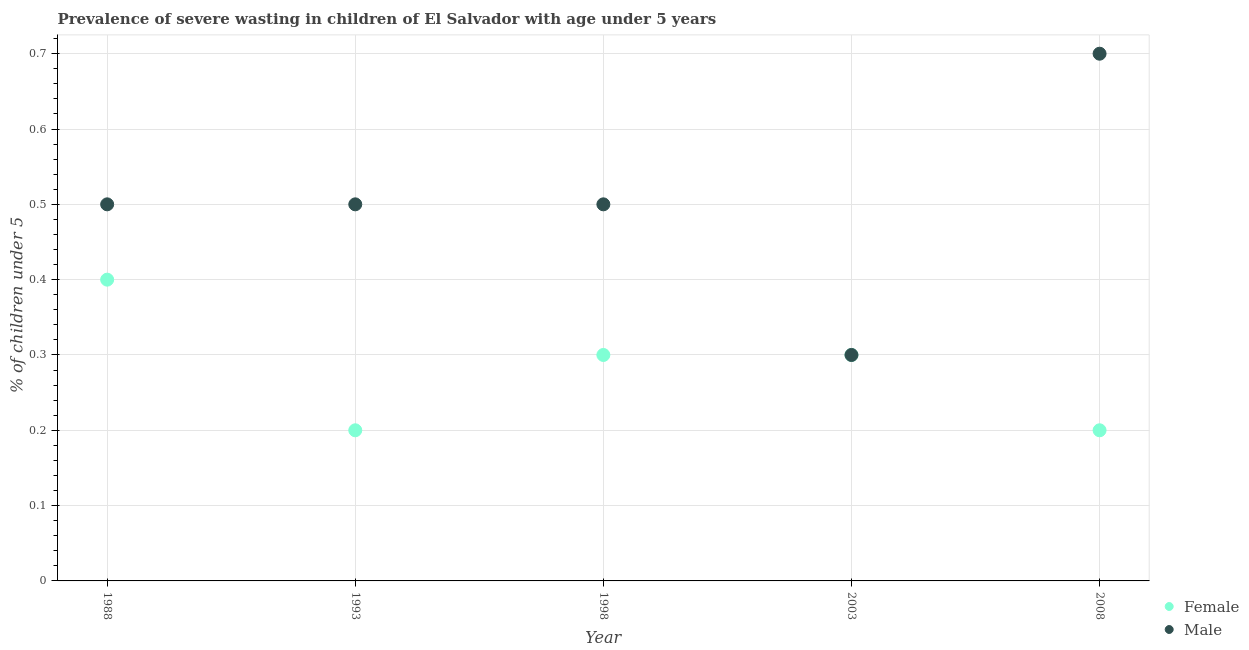Is the number of dotlines equal to the number of legend labels?
Keep it short and to the point. Yes. What is the percentage of undernourished female children in 2003?
Your answer should be very brief. 0.3. Across all years, what is the maximum percentage of undernourished male children?
Your response must be concise. 0.7. Across all years, what is the minimum percentage of undernourished female children?
Offer a very short reply. 0.2. In which year was the percentage of undernourished male children maximum?
Your answer should be very brief. 2008. What is the difference between the percentage of undernourished male children in 1993 and that in 2003?
Keep it short and to the point. 0.2. What is the difference between the percentage of undernourished male children in 1993 and the percentage of undernourished female children in 2008?
Your answer should be very brief. 0.3. In the year 2003, what is the difference between the percentage of undernourished male children and percentage of undernourished female children?
Give a very brief answer. 0. In how many years, is the percentage of undernourished female children greater than 0.02 %?
Provide a short and direct response. 5. Is the percentage of undernourished female children in 2003 less than that in 2008?
Your answer should be very brief. No. Is the difference between the percentage of undernourished male children in 1988 and 2008 greater than the difference between the percentage of undernourished female children in 1988 and 2008?
Your answer should be compact. No. What is the difference between the highest and the second highest percentage of undernourished male children?
Make the answer very short. 0.2. What is the difference between the highest and the lowest percentage of undernourished male children?
Offer a very short reply. 0.4. Does the percentage of undernourished female children monotonically increase over the years?
Ensure brevity in your answer.  No. Is the percentage of undernourished male children strictly greater than the percentage of undernourished female children over the years?
Offer a very short reply. No. How many dotlines are there?
Keep it short and to the point. 2. How many years are there in the graph?
Your answer should be very brief. 5. What is the difference between two consecutive major ticks on the Y-axis?
Give a very brief answer. 0.1. Are the values on the major ticks of Y-axis written in scientific E-notation?
Make the answer very short. No. Does the graph contain any zero values?
Ensure brevity in your answer.  No. Where does the legend appear in the graph?
Provide a short and direct response. Bottom right. How are the legend labels stacked?
Your response must be concise. Vertical. What is the title of the graph?
Your answer should be compact. Prevalence of severe wasting in children of El Salvador with age under 5 years. Does "2012 US$" appear as one of the legend labels in the graph?
Make the answer very short. No. What is the label or title of the Y-axis?
Your response must be concise.  % of children under 5. What is the  % of children under 5 in Female in 1988?
Offer a terse response. 0.4. What is the  % of children under 5 of Male in 1988?
Offer a very short reply. 0.5. What is the  % of children under 5 in Female in 1993?
Provide a succinct answer. 0.2. What is the  % of children under 5 in Female in 1998?
Offer a very short reply. 0.3. What is the  % of children under 5 in Female in 2003?
Ensure brevity in your answer.  0.3. What is the  % of children under 5 of Male in 2003?
Keep it short and to the point. 0.3. What is the  % of children under 5 in Female in 2008?
Offer a very short reply. 0.2. What is the  % of children under 5 of Male in 2008?
Give a very brief answer. 0.7. Across all years, what is the maximum  % of children under 5 of Female?
Your response must be concise. 0.4. Across all years, what is the maximum  % of children under 5 in Male?
Your answer should be very brief. 0.7. Across all years, what is the minimum  % of children under 5 in Female?
Your response must be concise. 0.2. Across all years, what is the minimum  % of children under 5 of Male?
Offer a terse response. 0.3. What is the difference between the  % of children under 5 in Male in 1988 and that in 1993?
Offer a terse response. 0. What is the difference between the  % of children under 5 in Male in 1988 and that in 1998?
Give a very brief answer. 0. What is the difference between the  % of children under 5 in Female in 1988 and that in 2003?
Offer a very short reply. 0.1. What is the difference between the  % of children under 5 in Female in 1988 and that in 2008?
Keep it short and to the point. 0.2. What is the difference between the  % of children under 5 in Male in 1988 and that in 2008?
Your answer should be very brief. -0.2. What is the difference between the  % of children under 5 of Female in 1993 and that in 1998?
Provide a short and direct response. -0.1. What is the difference between the  % of children under 5 of Male in 1993 and that in 2003?
Offer a terse response. 0.2. What is the difference between the  % of children under 5 in Male in 1993 and that in 2008?
Give a very brief answer. -0.2. What is the difference between the  % of children under 5 of Male in 1998 and that in 2003?
Ensure brevity in your answer.  0.2. What is the difference between the  % of children under 5 in Female in 1998 and that in 2008?
Keep it short and to the point. 0.1. What is the difference between the  % of children under 5 of Female in 2003 and that in 2008?
Your answer should be compact. 0.1. What is the difference between the  % of children under 5 of Male in 2003 and that in 2008?
Offer a terse response. -0.4. What is the difference between the  % of children under 5 in Female in 1988 and the  % of children under 5 in Male in 1993?
Offer a very short reply. -0.1. What is the difference between the  % of children under 5 in Female in 1988 and the  % of children under 5 in Male in 1998?
Your answer should be compact. -0.1. What is the difference between the  % of children under 5 of Female in 1988 and the  % of children under 5 of Male in 2003?
Provide a succinct answer. 0.1. What is the difference between the  % of children under 5 of Female in 1993 and the  % of children under 5 of Male in 2003?
Your response must be concise. -0.1. What is the difference between the  % of children under 5 of Female in 1993 and the  % of children under 5 of Male in 2008?
Your answer should be very brief. -0.5. What is the average  % of children under 5 in Female per year?
Offer a terse response. 0.28. In the year 1993, what is the difference between the  % of children under 5 of Female and  % of children under 5 of Male?
Your answer should be compact. -0.3. In the year 2003, what is the difference between the  % of children under 5 in Female and  % of children under 5 in Male?
Keep it short and to the point. 0. In the year 2008, what is the difference between the  % of children under 5 of Female and  % of children under 5 of Male?
Offer a terse response. -0.5. What is the ratio of the  % of children under 5 in Female in 1988 to that in 1993?
Offer a very short reply. 2. What is the ratio of the  % of children under 5 of Male in 1988 to that in 1993?
Ensure brevity in your answer.  1. What is the ratio of the  % of children under 5 in Female in 1988 to that in 1998?
Ensure brevity in your answer.  1.33. What is the ratio of the  % of children under 5 of Male in 1988 to that in 2008?
Your answer should be compact. 0.71. What is the ratio of the  % of children under 5 of Female in 1993 to that in 2003?
Your answer should be compact. 0.67. What is the ratio of the  % of children under 5 of Male in 1993 to that in 2003?
Provide a succinct answer. 1.67. What is the ratio of the  % of children under 5 in Female in 1993 to that in 2008?
Give a very brief answer. 1. What is the ratio of the  % of children under 5 in Male in 1993 to that in 2008?
Provide a short and direct response. 0.71. What is the ratio of the  % of children under 5 of Male in 1998 to that in 2003?
Keep it short and to the point. 1.67. What is the ratio of the  % of children under 5 of Female in 1998 to that in 2008?
Offer a very short reply. 1.5. What is the ratio of the  % of children under 5 of Female in 2003 to that in 2008?
Keep it short and to the point. 1.5. What is the ratio of the  % of children under 5 of Male in 2003 to that in 2008?
Your response must be concise. 0.43. What is the difference between the highest and the second highest  % of children under 5 in Female?
Your answer should be compact. 0.1. What is the difference between the highest and the lowest  % of children under 5 of Male?
Make the answer very short. 0.4. 